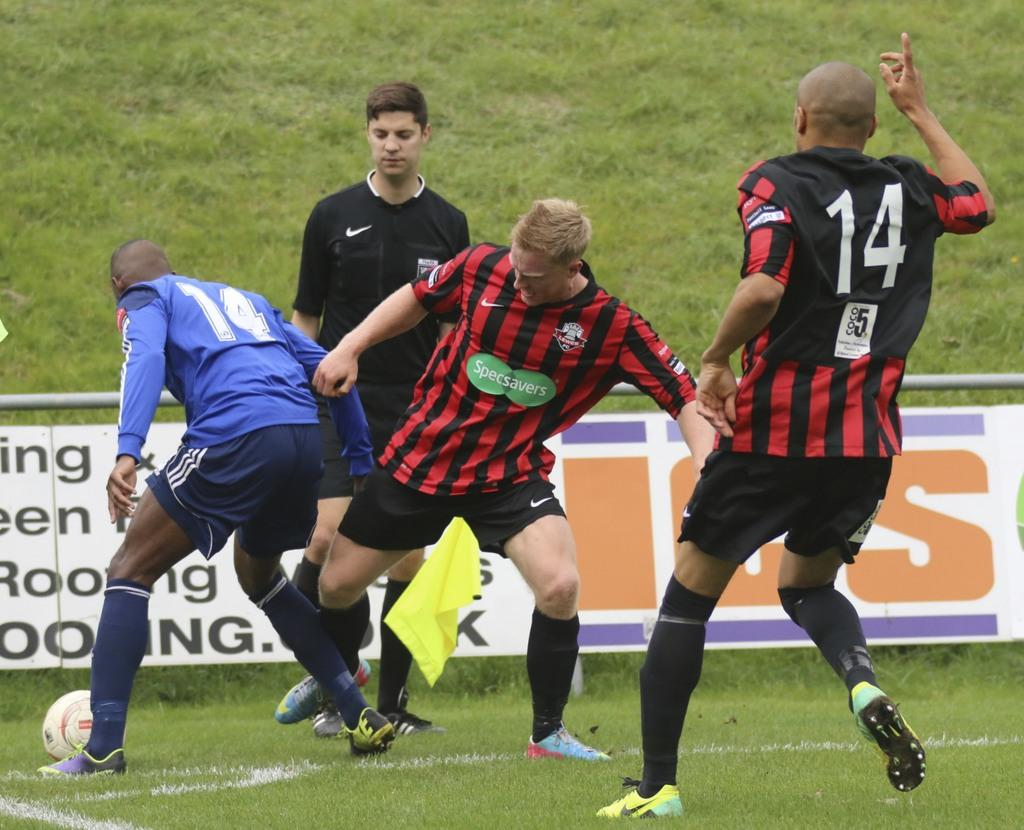<image>
Provide a brief description of the given image. men playing soccer in a blue 14 jersey and red and white 14 jersey 